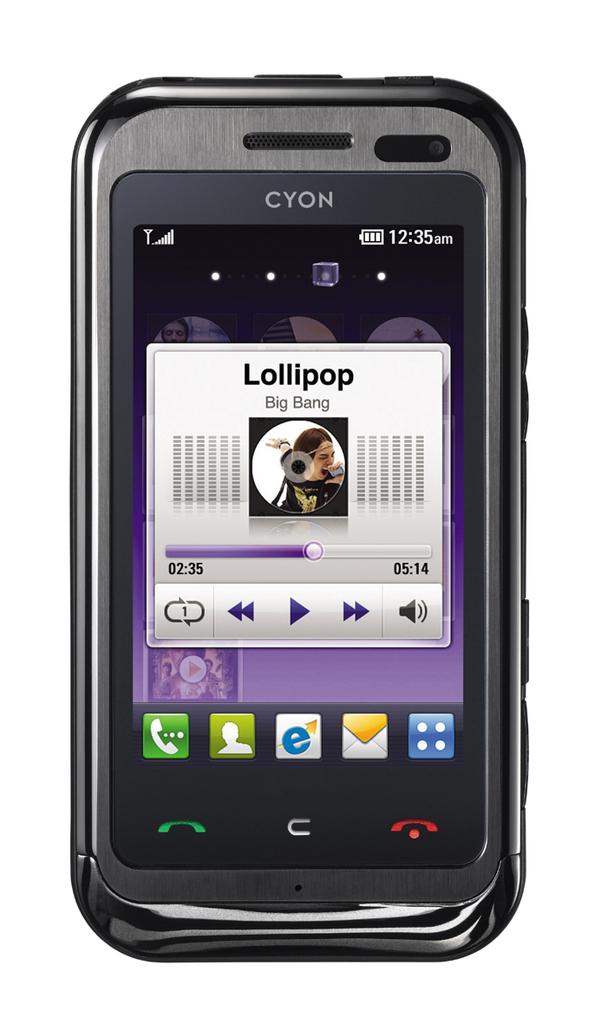What time is shown on this phone?
Your response must be concise. 12:35 am. What brand of phone is this?
Provide a succinct answer. Cyon. 